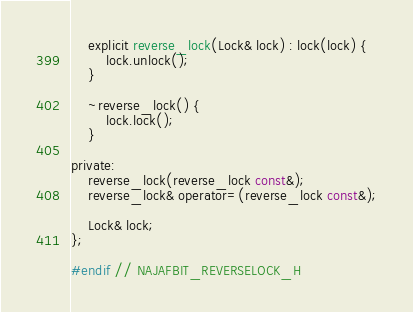Convert code to text. <code><loc_0><loc_0><loc_500><loc_500><_C_>    explicit reverse_lock(Lock& lock) : lock(lock) {
        lock.unlock();
    }

    ~reverse_lock() {
        lock.lock();
    }

private:
    reverse_lock(reverse_lock const&);
    reverse_lock& operator=(reverse_lock const&);

    Lock& lock;
};

#endif // NAJAFBIT_REVERSELOCK_H
</code> 